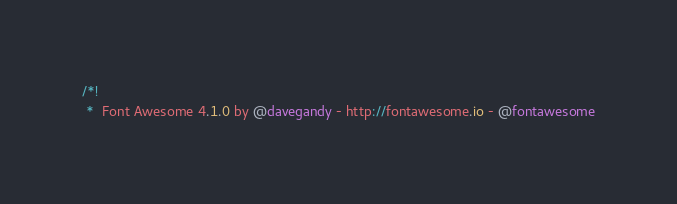<code> <loc_0><loc_0><loc_500><loc_500><_CSS_>/*!
 *  Font Awesome 4.1.0 by @davegandy - http://fontawesome.io - @fontawesome</code> 